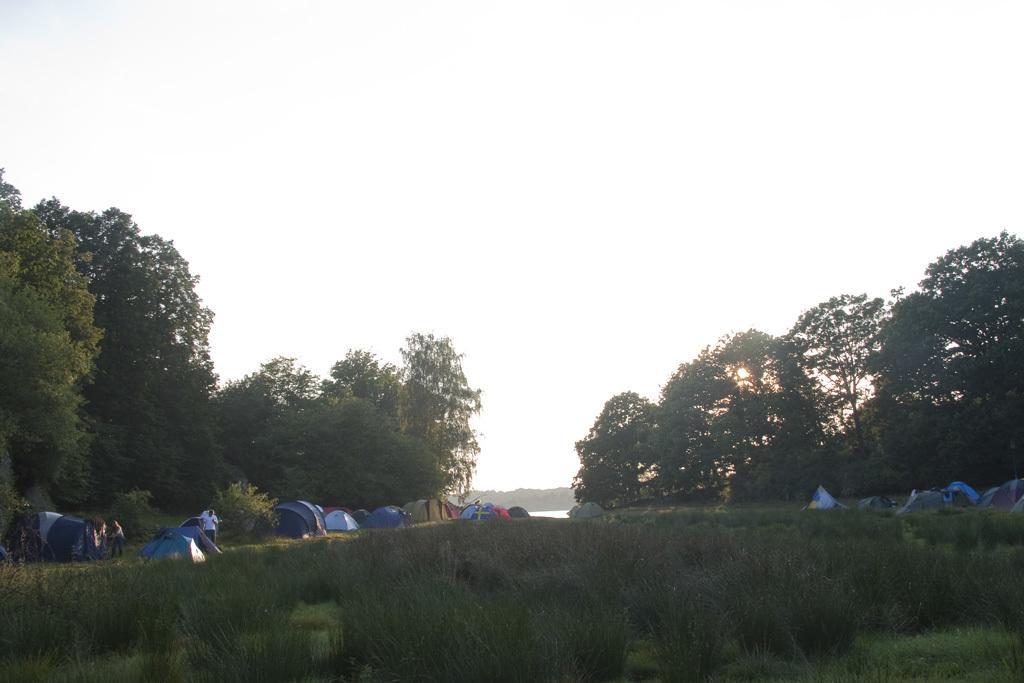Can you describe this image briefly? In this image at front there's grass on the surface. On the backside there are tents and people are standing beside the tents. In the background there are trees, water and sky. 